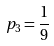Convert formula to latex. <formula><loc_0><loc_0><loc_500><loc_500>p _ { 3 } = \frac { 1 } { 9 }</formula> 